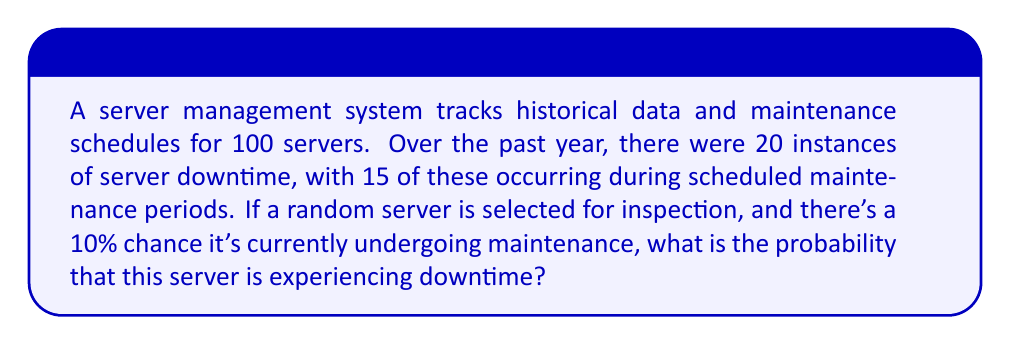Teach me how to tackle this problem. Let's approach this step-by-step using conditional probability:

1) Define events:
   D: Server is experiencing downtime
   M: Server is undergoing maintenance

2) Given information:
   P(M) = 10% = 0.1 (probability of maintenance)
   P(D) = 20/100 = 0.2 (overall probability of downtime)
   P(D|M) = 15/20 = 0.75 (probability of downtime given maintenance)

3) We need to find P(D) using the law of total probability:
   $$P(D) = P(D|M) \cdot P(M) + P(D|\text{not }M) \cdot P(\text{not }M)$$

4) We know P(D|M), P(M), and P(D). Let's find P(D|not M):
   $$0.2 = 0.75 \cdot 0.1 + P(D|\text{not }M) \cdot 0.9$$
   $$0.2 - 0.075 = P(D|\text{not }M) \cdot 0.9$$
   $$P(D|\text{not }M) = \frac{0.125}{0.9} \approx 0.139$$

5) Now we can use Bayes' theorem to find P(D):
   $$P(D) = P(D|M) \cdot P(M) + P(D|\text{not }M) \cdot P(\text{not }M)$$
   $$P(D) = 0.75 \cdot 0.1 + 0.139 \cdot 0.9$$
   $$P(D) = 0.075 + 0.125 = 0.2$$

Therefore, the probability that the selected server is experiencing downtime is 0.2 or 20%.
Answer: 0.2 